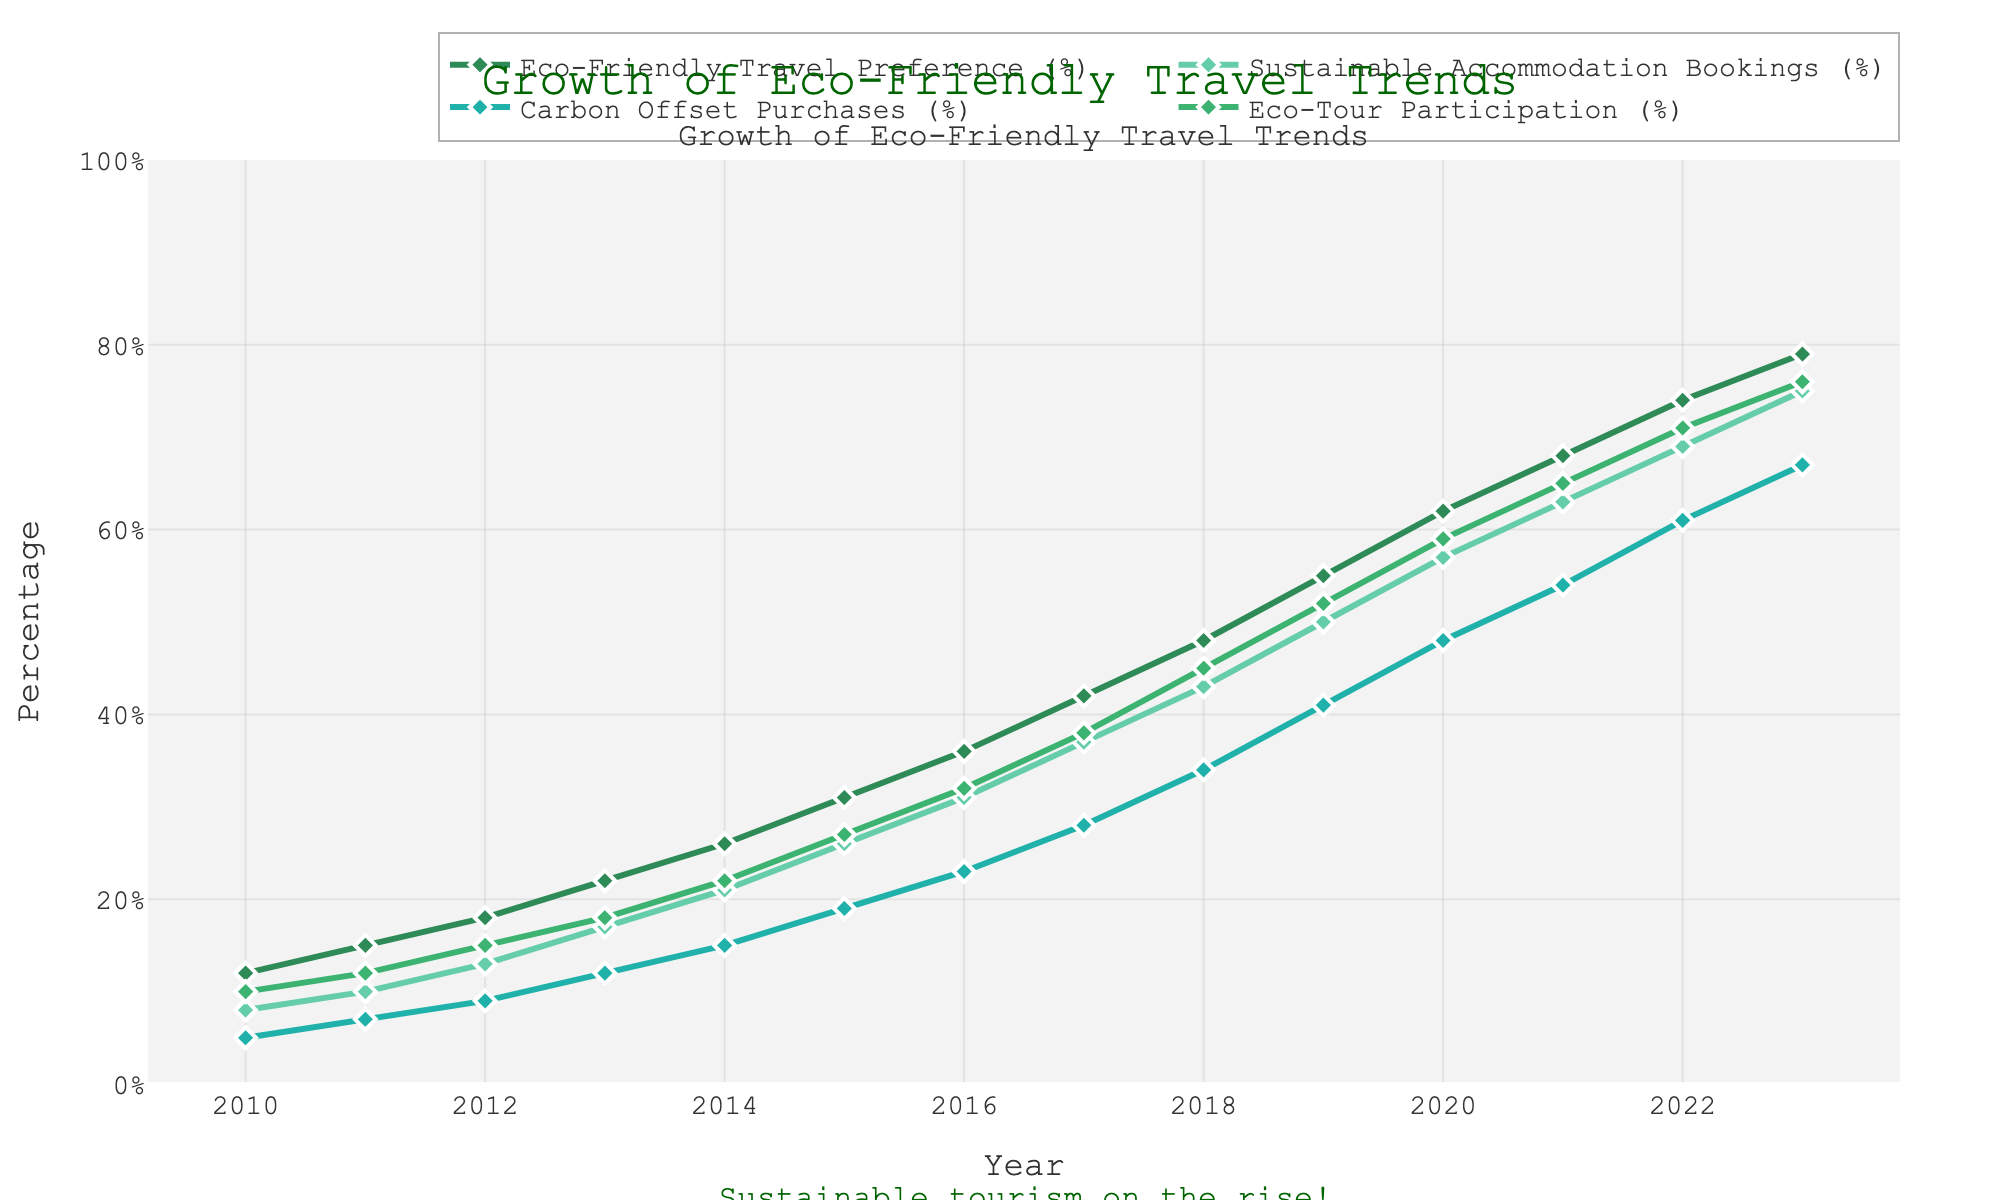What is the value of Eco-Friendly Travel Preference in 2015? Look at the line representing Eco-Friendly Travel Preference. At the year 2015, the value is 31% as indicated by the point and label.
Answer: 31% What was the growth in Sustainable Accommodation Bookings (%) from 2010 to 2023? Locate the Sustainable Accommodation Bookings line. In 2010, the value is 8%, and in 2023, it is 75%. The growth is calculated as 75 - 8 = 67%.
Answer: 67% By how much did Carbon Offset Purchases (%) increase from 2021 to 2023? Check the Carbon Offset Purchases line. In 2021, the value is 54%, and in 2023, it's 67%. The increase is 67 - 54 = 13%.
Answer: 13% Which trend shows the largest increase from 2010 to 2023? Compare the initial and final values of all trends. Eco-Friendly Travel Preference increased from 12% to 79%, Sustainable Accommodation Bookings from 8% to 75%, Carbon Offset Purchases from 5% to 67%, and Eco-Tour Participation from 10% to 76%. The largest increase is in Eco-Friendly Travel Preference, from 12% to 79%, a total increase of 67%.
Answer: Eco-Friendly Travel Preference In which year did Eco-Tour Participation surpass 50%? Look at the Eco-Tour Participation line and check where it crosses 50%. It appears to surpass 50% in the year 2019.
Answer: 2019 How do the values of all metrics compare in 2020? Refer to the figure for 2020 values. Eco-Friendly Travel Preference is 62%, Sustainable Accommodation Bookings is 57%, Carbon Offset Purchases are 48%, and Eco-Tour Participation is 59%. Comparing these, Eco-Friendly Travel Preference is the highest and Carbon Offset Purchases are the lowest.
Answer: Eco-Friendly Travel Preference: 62%, Sustainable Accommodation Bookings: 57%, Carbon Offset Purchases: 48%, Eco-Tour Participation: 59% Between which consecutive years did Sustainable Accommodation Bookings see its highest growth rate? Look at the steepest slope in the Sustainable Accommodation Bookings line. The steepest growth appears to be between 2014 and 2015 (from 21% to 26%), an increase of 5%.
Answer: Between 2014 and 2015 What is the average value of Eco-Tour Participation from 2010 to 2023? Sum up the values of Eco-Tour Participation from 2010 to 2023 and divide by the number of years. (10+12+15+18+22+27+32+38+45+52+59+65+71+76) / 14 = 44.86%.
Answer: 44.86% Which color represents the Sustainable Accommodation Bookings trend on the chart? Identify the color used for the Sustainable Accommodation Bookings line. It is a shade of light green.
Answer: Light green If the current trend continues, when is it likely that Eco-Friendly Travel Preferences will reach 90%? Notice the growth trend for Eco-Friendly Travel Preferences. If the trend continues as it has been increasing roughly by 5% each year recently, it is likely to reach 90% in approximately 2-3 years from 2023, which would be around 2025-2026.
Answer: Around 2025-2026 